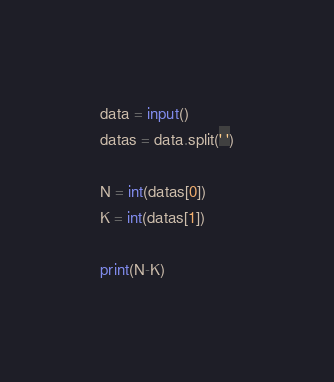Convert code to text. <code><loc_0><loc_0><loc_500><loc_500><_Python_>data = input()
datas = data.split(' ')

N = int(datas[0])
K = int(datas[1])

print(N-K)</code> 